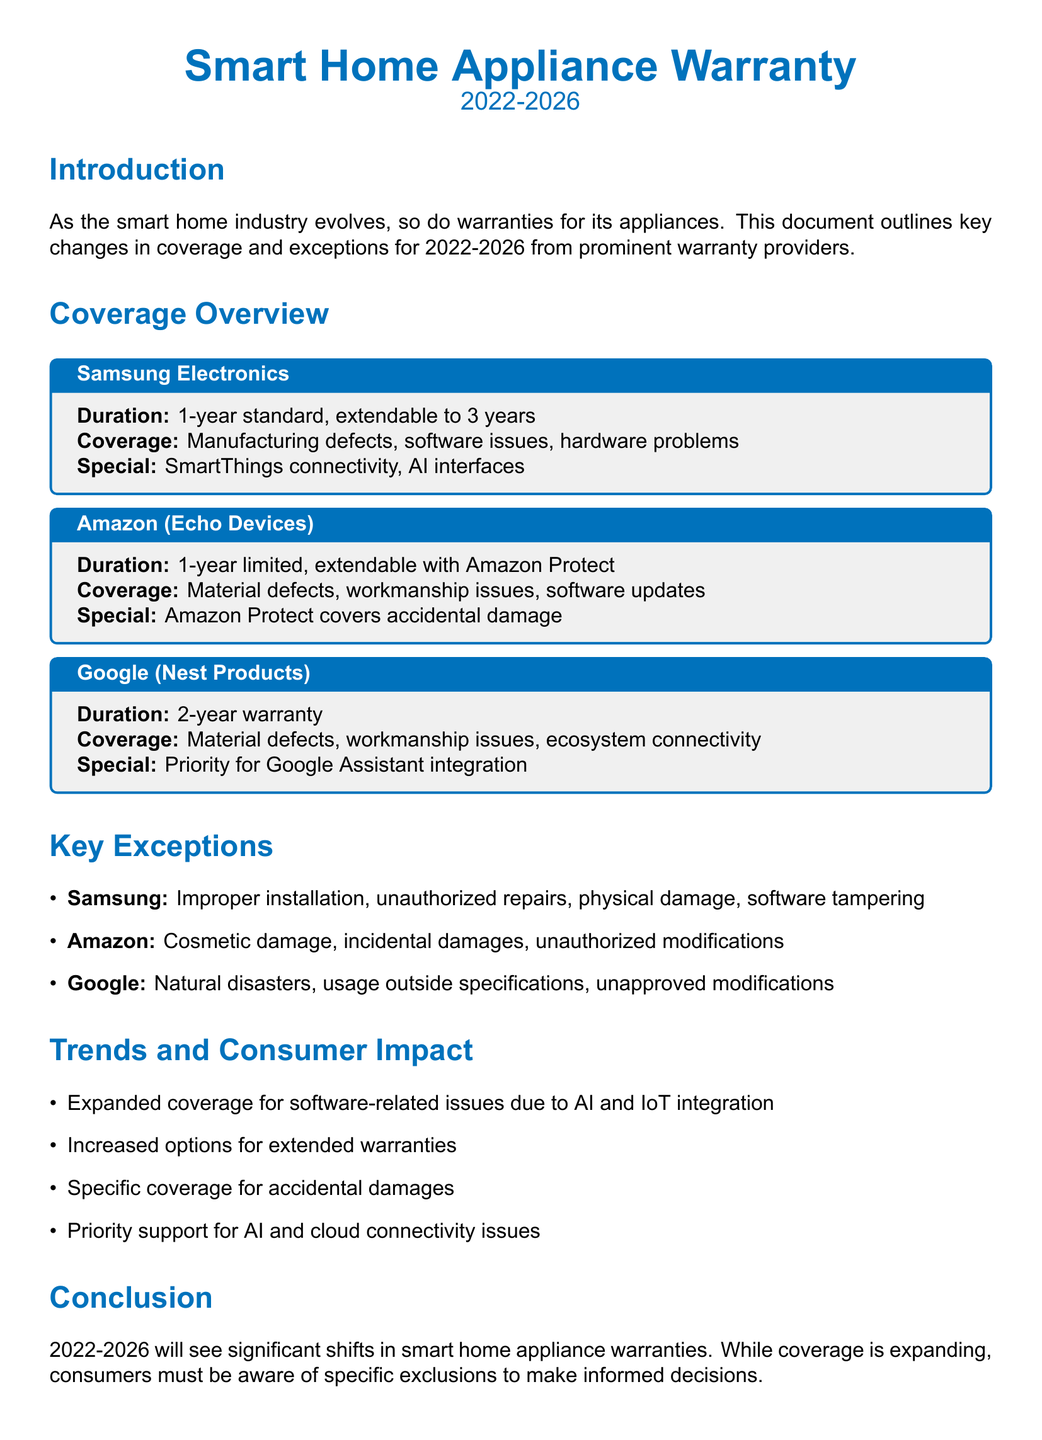what is the duration of Samsung's standard warranty? The document states that Samsung's standard warranty duration is 1 year, which can be extendable to 3 years.
Answer: 1-year what defects does Samsung's warranty cover? Samsung's warranty covers manufacturing defects, software issues, and hardware problems.
Answer: Manufacturing defects, software issues, hardware problems how long is Google’s warranty period for Nest products? The document specifies that Google's warranty period for Nest products is 2 years.
Answer: 2 years what special feature is covered by Amazon Protect for Echo Devices? The document mentions that Amazon Protect covers accidental damage to Echo Devices.
Answer: Accidental damage which warranty provider offers priority for AI integration? The document indicates that Google's warranty provides priority for Google Assistant integration.
Answer: Google what are two key exceptions for Samsung's warranty? Samsung's warranty exceptions include improper installation and unauthorized repairs.
Answer: Improper installation, unauthorized repairs how has coverage expanded in smart home appliance warranties? The document notes expanded coverage for software-related issues due to AI and IoT integration.
Answer: Software-related issues what is the trend regarding extended warranties? The document highlights that there are increased options for extended warranties.
Answer: Increased options which warranty excludes cosmetic damage? According to the document, Amazon's warranty excludes cosmetic damage.
Answer: Amazon 